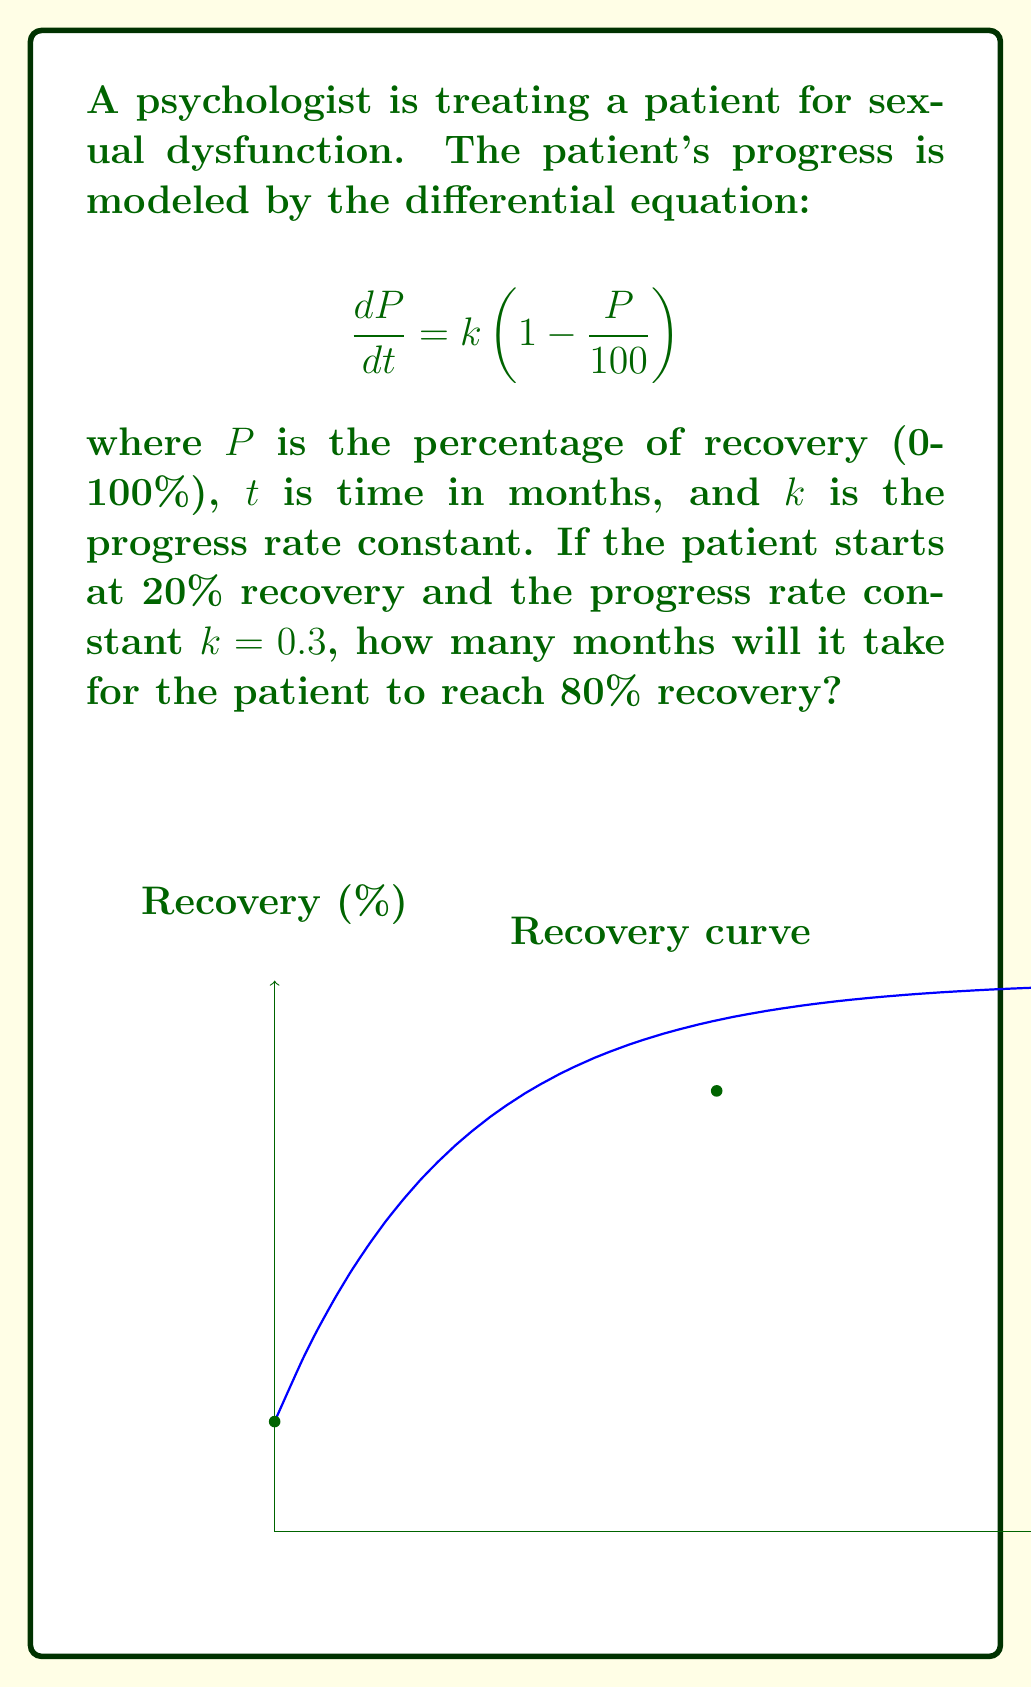Can you solve this math problem? To solve this problem, we follow these steps:

1) The given differential equation is a logistic growth model. Its solution is:

   $$P(t) = \frac{100}{1 + (\frac{100}{P_0} - 1)e^{-kt}}$$

   where $P_0$ is the initial percentage of recovery.

2) We're given:
   $P_0 = 20\%$
   $k = 0.3$
   We need to find $t$ when $P(t) = 80\%$

3) Substituting these values into the equation:

   $$80 = \frac{100}{1 + (\frac{100}{20} - 1)e^{-0.3t}}$$

4) Simplify:
   $$80 = \frac{100}{1 + 4e^{-0.3t}}$$

5) Solve for $t$:
   $$1 + 4e^{-0.3t} = \frac{100}{80} = 1.25$$
   $$4e^{-0.3t} = 0.25$$
   $$e^{-0.3t} = 0.0625$$
   $$-0.3t = \ln(0.0625) = -2.7726$$
   $$t = \frac{2.7726}{0.3} = 9.2420$$

6) Therefore, it will take approximately 9.24 months to reach 80% recovery.
Answer: 9.24 months 